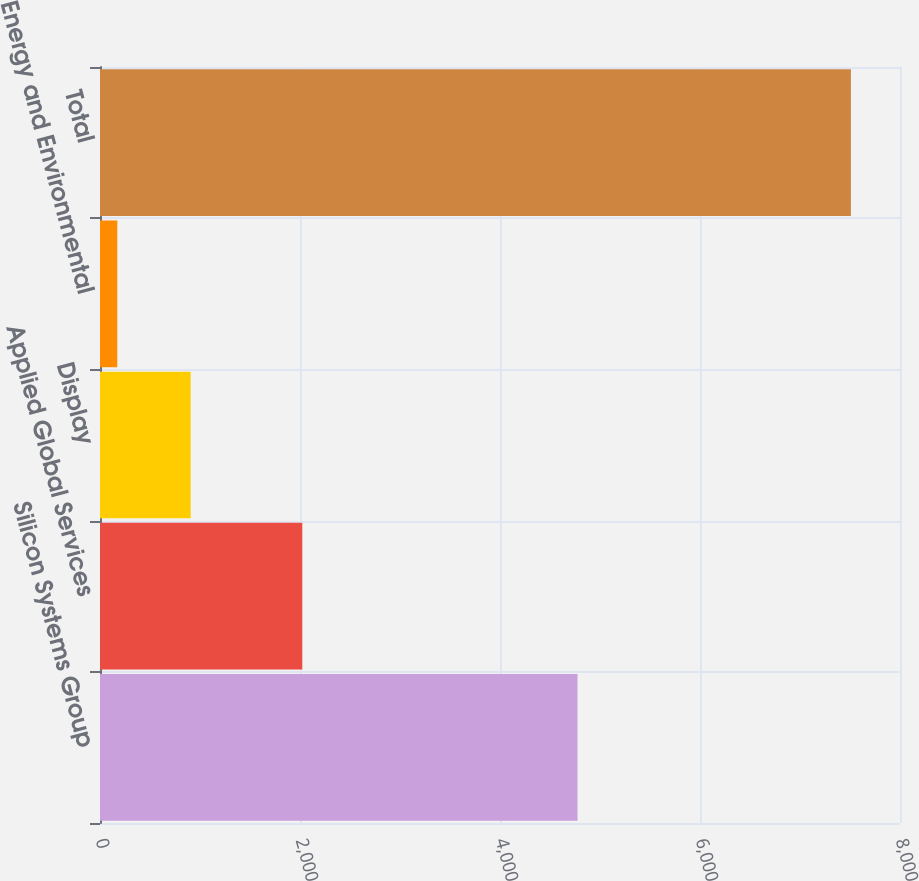Convert chart to OTSL. <chart><loc_0><loc_0><loc_500><loc_500><bar_chart><fcel>Silicon Systems Group<fcel>Applied Global Services<fcel>Display<fcel>Energy and Environmental<fcel>Total<nl><fcel>4775<fcel>2023<fcel>906.6<fcel>173<fcel>7509<nl></chart> 